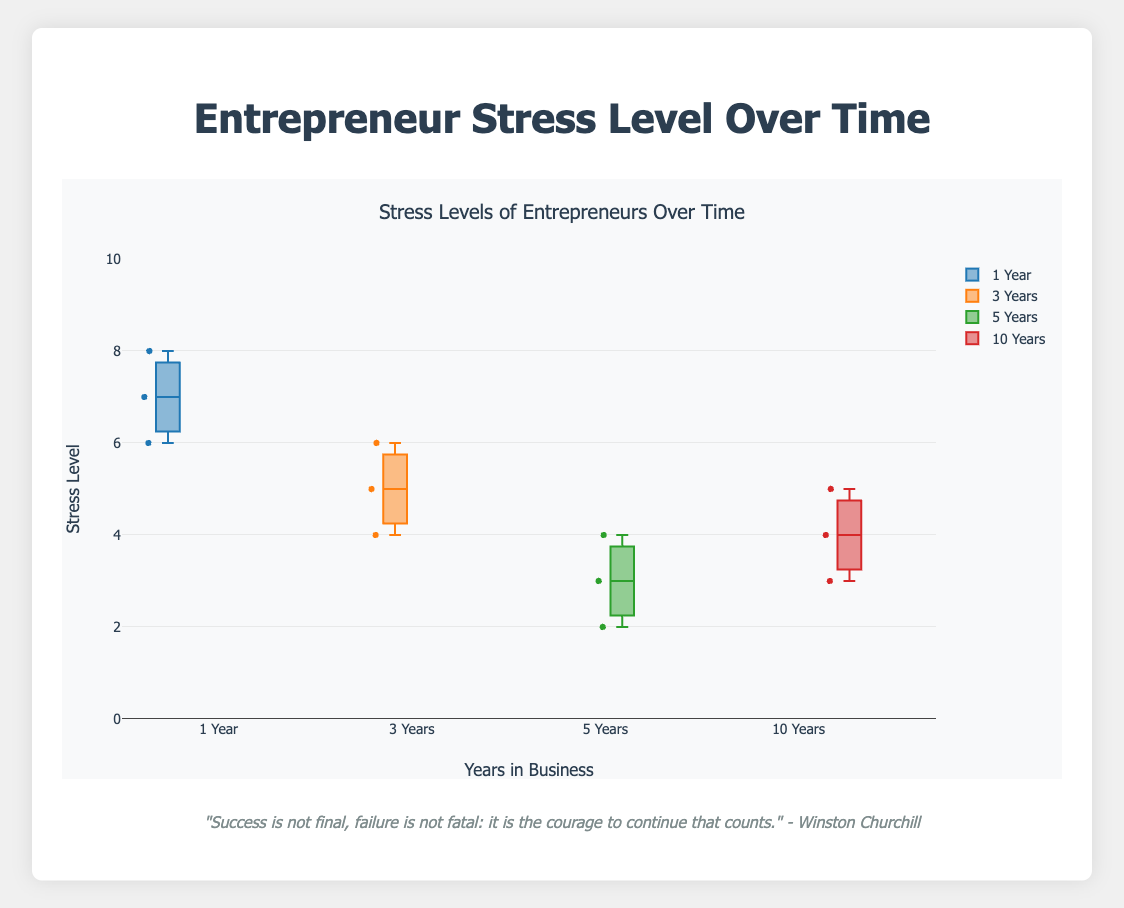What's the title of the plot? The title is generally located at the top of the plot and serves to describe the primary subject of the visualization. Here, it is clearly stated as "Stress Levels of Entrepreneurs Over Time".
Answer: Stress Levels of Entrepreneurs Over Time What do the y-axis and x-axis represent? The y-axis title "Stress Level" indicates it is measuring stress levels on a numeric scale likely from 0 to 10. The x-axis title "Years in Business" signifies the x-axis categorizes entrepreneurs based on the number of years they have been in business.
Answer: Stress Level and Years in Business Which group has the highest median stress level? Median values in a box plot are represented by the line inside each box. By visually comparing the medians of each group's box, the "1 Year" group has the highest median stress level.
Answer: 1 Year What is the range of stress levels for entrepreneurs with 5 years in business? The range in a box plot is the span from the lowest point (minimum) to the highest point (maximum), including any outliers. For the "5 Years" group, the range extends from about 2 to 4.
Answer: 2 to 4 Which group has the widest interquartile range (IQR) for stress levels? The IQR is the length of the box in the box plot, representing the middle 50% of the data. The "1 Year" group has the widest box, indicating the largest IQR.
Answer: 1 Year Are there any outliers present in the data? Outliers in a box plot are typically represented by individual points outside the whiskers. Visually inspecting the plot, there don't appear to be any points falling outside the whiskers.
Answer: No How does the median stress level change from 1 year to 10 years in business? By comparing the median lines of each box, the median stress level decreases as the years in business increase, from highest at 1 year to lowest at 10 years.
Answer: Decreases What is the stress level spread for entrepreneurs with 3 years in business? The spread is the distance between the minimum and maximum whiskers. For the "3 Years" group, it spans from 4 to 6.
Answer: 4 to 6 Are the stress levels more consistent for entrepreneurs with 10 years in business compared to those with 1 year in business? Consistency in a box plot can be inferred from the IQR; a smaller IQR suggests more consistency. "10 Years" has a narrower box compared to "1 Year", indicating more consistent stress levels.
Answer: Yes Which group shows the most variability in stress levels? Variability can be deduced from the length of the whiskers and the size of the IQR. The "1 Year" group shows the most variability with longer whiskers and a larger IQR.
Answer: 1 Year 